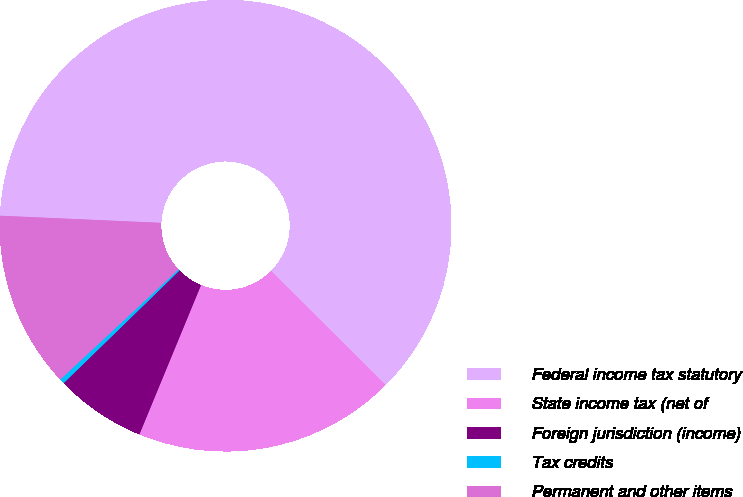<chart> <loc_0><loc_0><loc_500><loc_500><pie_chart><fcel>Federal income tax statutory<fcel>State income tax (net of<fcel>Foreign jurisdiction (income)<fcel>Tax credits<fcel>Permanent and other items<nl><fcel>61.75%<fcel>18.77%<fcel>6.49%<fcel>0.35%<fcel>12.63%<nl></chart> 